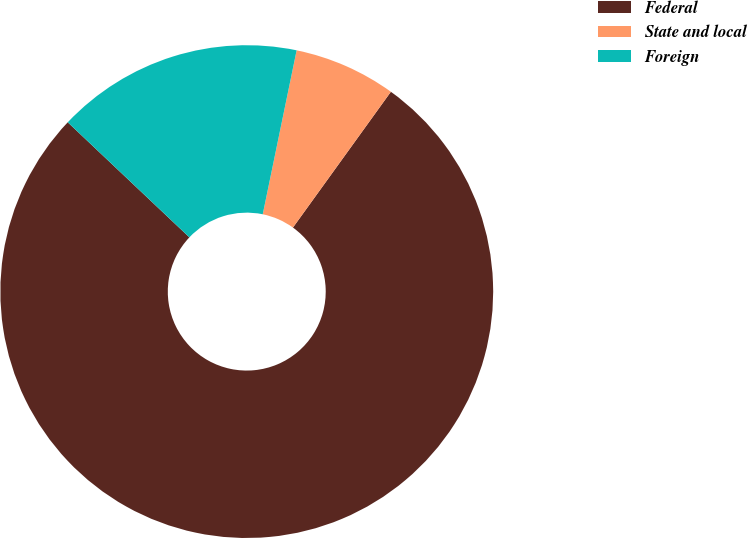Convert chart. <chart><loc_0><loc_0><loc_500><loc_500><pie_chart><fcel>Federal<fcel>State and local<fcel>Foreign<nl><fcel>77.12%<fcel>6.7%<fcel>16.19%<nl></chart> 